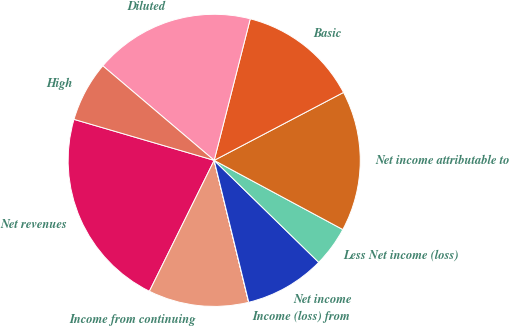<chart> <loc_0><loc_0><loc_500><loc_500><pie_chart><fcel>Net revenues<fcel>Income from continuing<fcel>Income (loss) from<fcel>Net income<fcel>Less Net income (loss)<fcel>Net income attributable to<fcel>Basic<fcel>Diluted<fcel>High<nl><fcel>22.21%<fcel>11.11%<fcel>0.01%<fcel>8.89%<fcel>4.45%<fcel>15.55%<fcel>13.33%<fcel>17.77%<fcel>6.67%<nl></chart> 